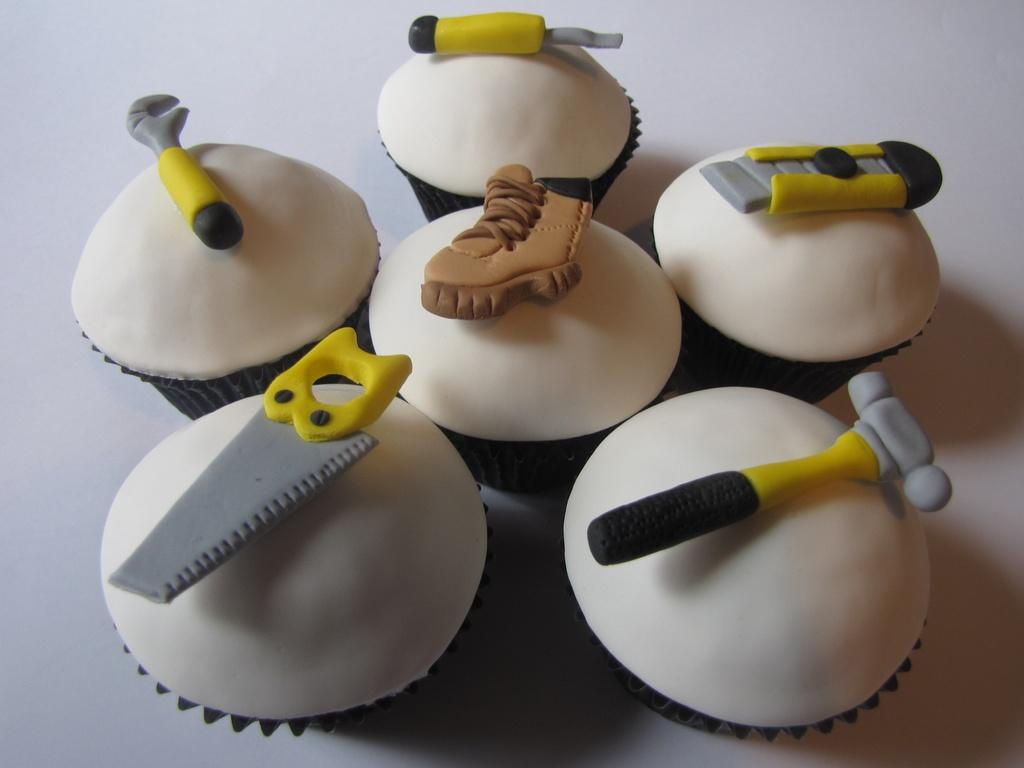What type of food items are present in the image? There are cupcakes in the image. What is placed on top of the cupcakes? There are tools and a shoe-like structured food item on top of the cupcakes. What type of building can be seen in the background of the image? There is no building visible in the image; it only features cupcakes with tools and a shoe-like structured food item on top. How many ladybugs are present on the cupcakes? There are no ladybugs present on the cupcakes in the image. 